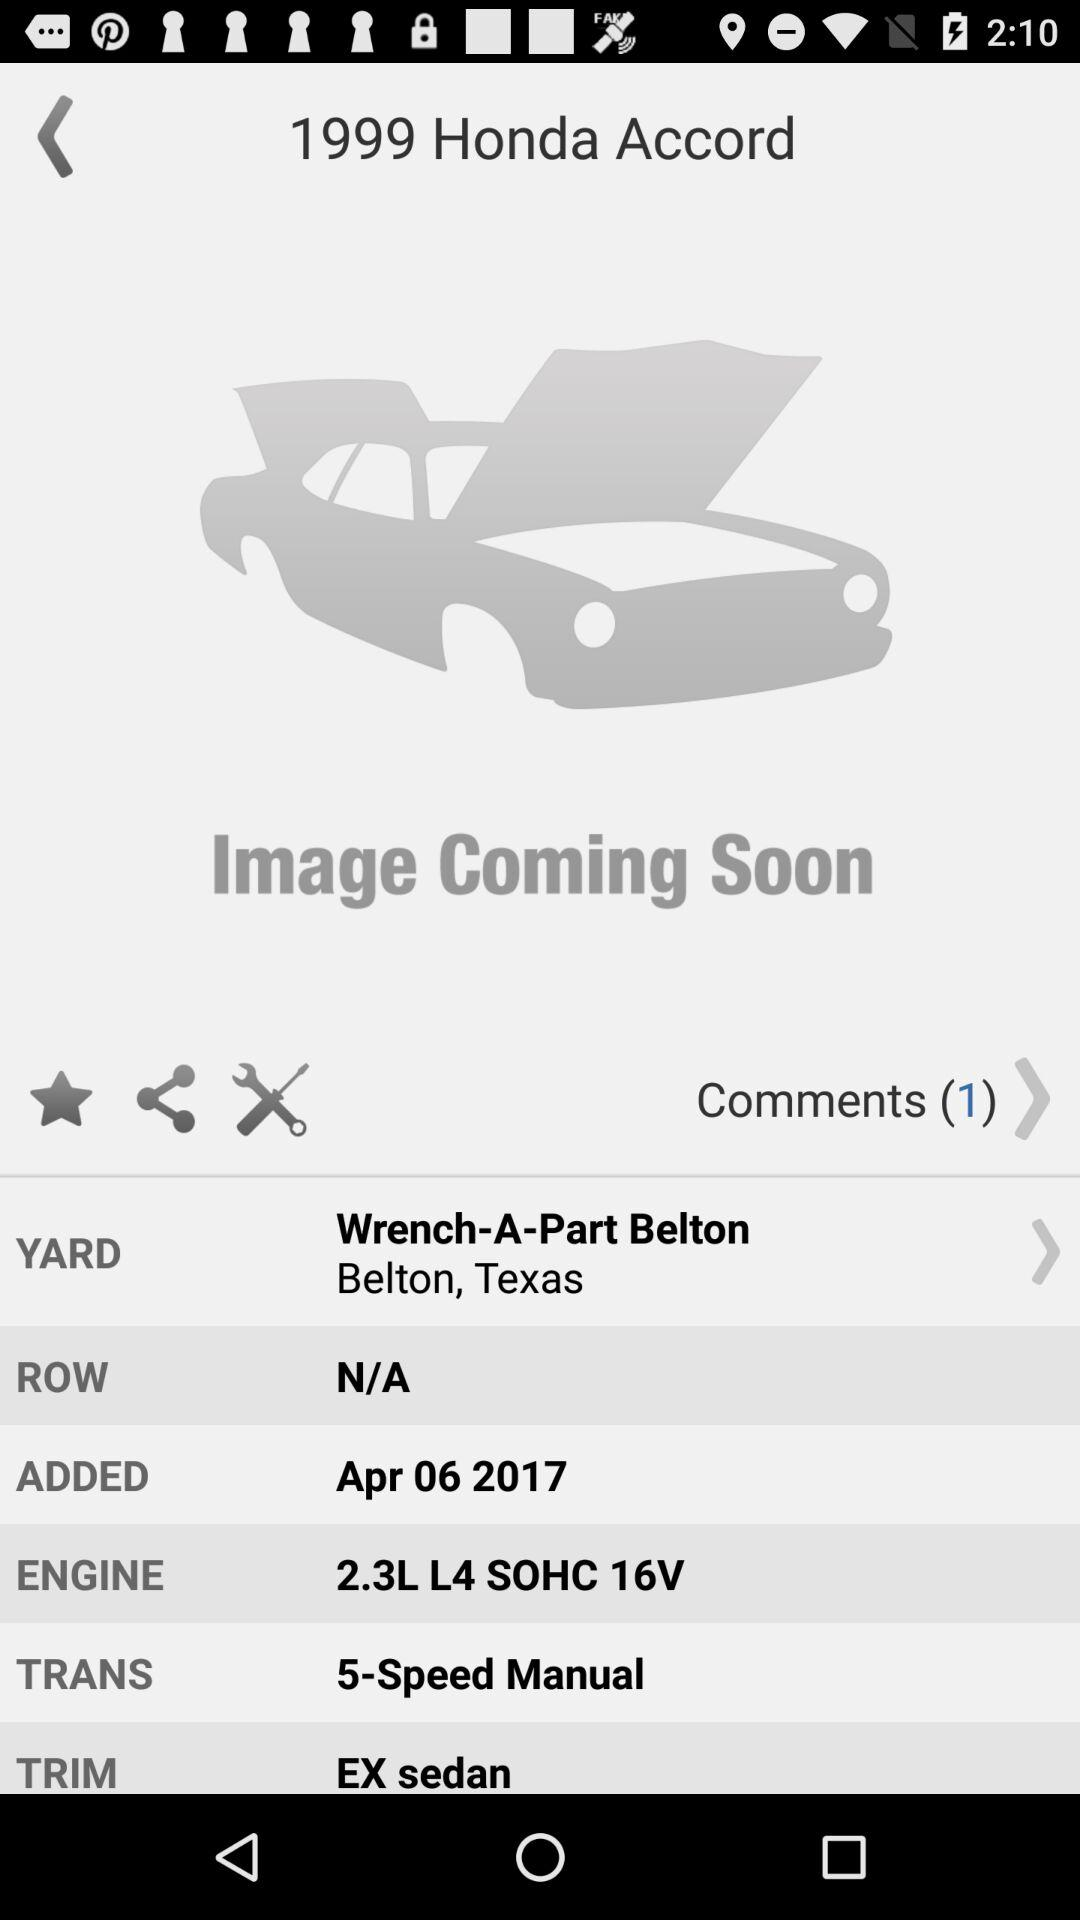Can you tell me more about the condition of this car? Based on the information provided in the image, the car's details were added to the inventory on April 6, 2017. While I cannot assess the car's current condition without a visual, it has been over six years since it was listed, which might suggest it may have significant wear or possibly been used for parts. 